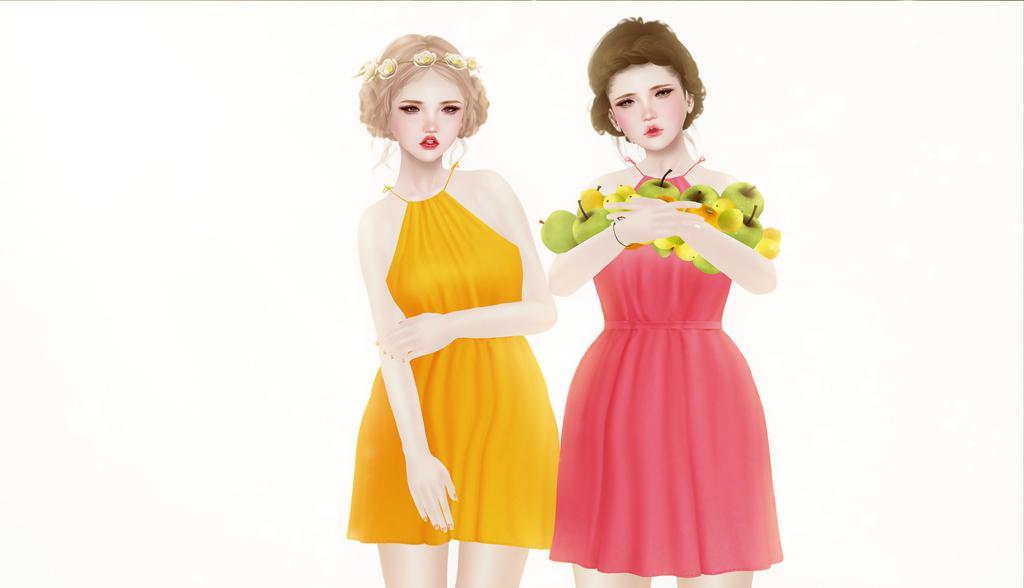Can you describe this image briefly? This is an animated image of two ladies. On lady is holding fruits in her hands. 